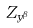<formula> <loc_0><loc_0><loc_500><loc_500>Z _ { y ^ { \beta } }</formula> 